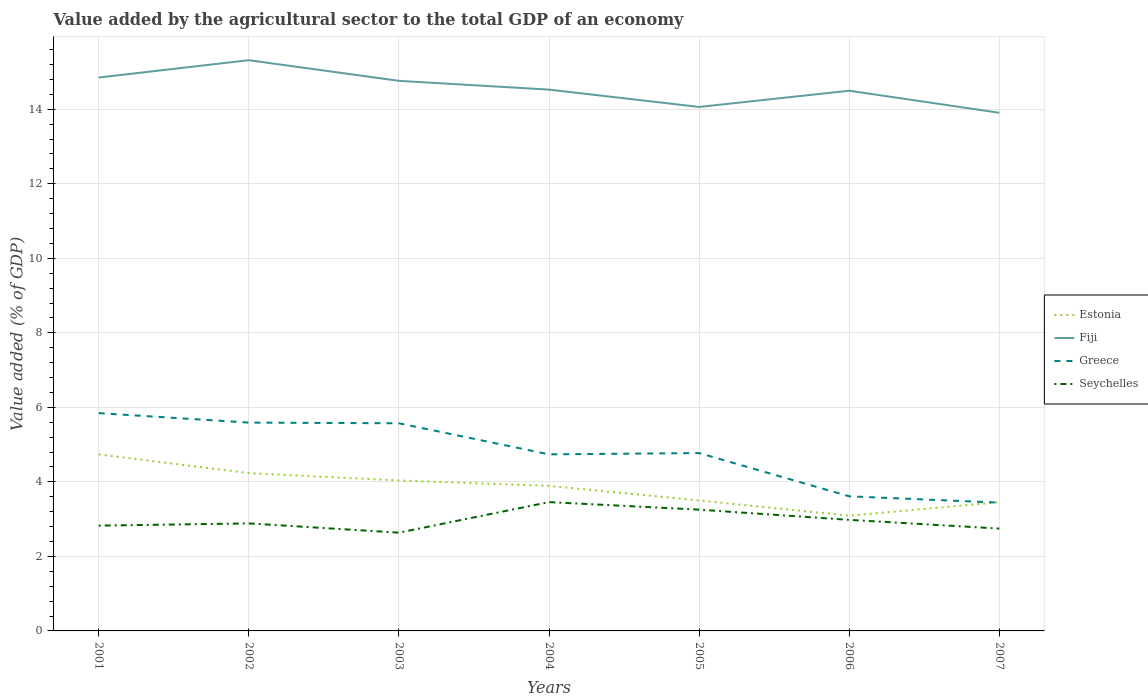How many different coloured lines are there?
Keep it short and to the point. 4. Across all years, what is the maximum value added by the agricultural sector to the total GDP in Fiji?
Your answer should be compact. 13.91. What is the total value added by the agricultural sector to the total GDP in Estonia in the graph?
Your answer should be compact. 1.14. What is the difference between the highest and the second highest value added by the agricultural sector to the total GDP in Fiji?
Give a very brief answer. 1.41. How many lines are there?
Your response must be concise. 4. How many years are there in the graph?
Your answer should be compact. 7. What is the difference between two consecutive major ticks on the Y-axis?
Your answer should be very brief. 2. Are the values on the major ticks of Y-axis written in scientific E-notation?
Offer a terse response. No. Does the graph contain grids?
Give a very brief answer. Yes. Where does the legend appear in the graph?
Your answer should be very brief. Center right. How many legend labels are there?
Offer a terse response. 4. What is the title of the graph?
Your answer should be compact. Value added by the agricultural sector to the total GDP of an economy. Does "Nigeria" appear as one of the legend labels in the graph?
Offer a terse response. No. What is the label or title of the Y-axis?
Give a very brief answer. Value added (% of GDP). What is the Value added (% of GDP) of Estonia in 2001?
Your answer should be very brief. 4.74. What is the Value added (% of GDP) of Fiji in 2001?
Your answer should be compact. 14.85. What is the Value added (% of GDP) of Greece in 2001?
Ensure brevity in your answer.  5.84. What is the Value added (% of GDP) in Seychelles in 2001?
Provide a succinct answer. 2.83. What is the Value added (% of GDP) in Estonia in 2002?
Provide a succinct answer. 4.23. What is the Value added (% of GDP) of Fiji in 2002?
Offer a terse response. 15.32. What is the Value added (% of GDP) of Greece in 2002?
Your answer should be compact. 5.59. What is the Value added (% of GDP) in Seychelles in 2002?
Provide a short and direct response. 2.89. What is the Value added (% of GDP) in Estonia in 2003?
Your answer should be compact. 4.04. What is the Value added (% of GDP) in Fiji in 2003?
Give a very brief answer. 14.76. What is the Value added (% of GDP) in Greece in 2003?
Offer a terse response. 5.57. What is the Value added (% of GDP) of Seychelles in 2003?
Your response must be concise. 2.64. What is the Value added (% of GDP) of Estonia in 2004?
Give a very brief answer. 3.89. What is the Value added (% of GDP) of Fiji in 2004?
Your response must be concise. 14.53. What is the Value added (% of GDP) in Greece in 2004?
Your answer should be very brief. 4.74. What is the Value added (% of GDP) in Seychelles in 2004?
Provide a short and direct response. 3.46. What is the Value added (% of GDP) in Estonia in 2005?
Provide a succinct answer. 3.5. What is the Value added (% of GDP) in Fiji in 2005?
Keep it short and to the point. 14.06. What is the Value added (% of GDP) in Greece in 2005?
Make the answer very short. 4.77. What is the Value added (% of GDP) in Seychelles in 2005?
Your answer should be compact. 3.25. What is the Value added (% of GDP) of Estonia in 2006?
Make the answer very short. 3.09. What is the Value added (% of GDP) of Fiji in 2006?
Offer a very short reply. 14.5. What is the Value added (% of GDP) in Greece in 2006?
Your answer should be compact. 3.61. What is the Value added (% of GDP) in Seychelles in 2006?
Give a very brief answer. 2.98. What is the Value added (% of GDP) in Estonia in 2007?
Offer a very short reply. 3.46. What is the Value added (% of GDP) of Fiji in 2007?
Your answer should be compact. 13.91. What is the Value added (% of GDP) in Greece in 2007?
Provide a short and direct response. 3.44. What is the Value added (% of GDP) of Seychelles in 2007?
Keep it short and to the point. 2.75. Across all years, what is the maximum Value added (% of GDP) of Estonia?
Ensure brevity in your answer.  4.74. Across all years, what is the maximum Value added (% of GDP) in Fiji?
Make the answer very short. 15.32. Across all years, what is the maximum Value added (% of GDP) of Greece?
Give a very brief answer. 5.84. Across all years, what is the maximum Value added (% of GDP) in Seychelles?
Ensure brevity in your answer.  3.46. Across all years, what is the minimum Value added (% of GDP) of Estonia?
Keep it short and to the point. 3.09. Across all years, what is the minimum Value added (% of GDP) of Fiji?
Ensure brevity in your answer.  13.91. Across all years, what is the minimum Value added (% of GDP) in Greece?
Provide a succinct answer. 3.44. Across all years, what is the minimum Value added (% of GDP) of Seychelles?
Make the answer very short. 2.64. What is the total Value added (% of GDP) in Estonia in the graph?
Give a very brief answer. 26.95. What is the total Value added (% of GDP) of Fiji in the graph?
Keep it short and to the point. 101.93. What is the total Value added (% of GDP) of Greece in the graph?
Provide a succinct answer. 33.58. What is the total Value added (% of GDP) of Seychelles in the graph?
Ensure brevity in your answer.  20.79. What is the difference between the Value added (% of GDP) of Estonia in 2001 and that in 2002?
Keep it short and to the point. 0.5. What is the difference between the Value added (% of GDP) of Fiji in 2001 and that in 2002?
Provide a succinct answer. -0.46. What is the difference between the Value added (% of GDP) of Greece in 2001 and that in 2002?
Make the answer very short. 0.25. What is the difference between the Value added (% of GDP) of Seychelles in 2001 and that in 2002?
Your answer should be very brief. -0.06. What is the difference between the Value added (% of GDP) of Estonia in 2001 and that in 2003?
Make the answer very short. 0.7. What is the difference between the Value added (% of GDP) in Fiji in 2001 and that in 2003?
Your response must be concise. 0.09. What is the difference between the Value added (% of GDP) in Greece in 2001 and that in 2003?
Provide a short and direct response. 0.27. What is the difference between the Value added (% of GDP) in Seychelles in 2001 and that in 2003?
Give a very brief answer. 0.19. What is the difference between the Value added (% of GDP) in Estonia in 2001 and that in 2004?
Your answer should be compact. 0.84. What is the difference between the Value added (% of GDP) in Fiji in 2001 and that in 2004?
Offer a very short reply. 0.32. What is the difference between the Value added (% of GDP) in Greece in 2001 and that in 2004?
Your answer should be very brief. 1.11. What is the difference between the Value added (% of GDP) of Seychelles in 2001 and that in 2004?
Ensure brevity in your answer.  -0.63. What is the difference between the Value added (% of GDP) of Estonia in 2001 and that in 2005?
Keep it short and to the point. 1.24. What is the difference between the Value added (% of GDP) in Fiji in 2001 and that in 2005?
Provide a short and direct response. 0.79. What is the difference between the Value added (% of GDP) of Greece in 2001 and that in 2005?
Provide a short and direct response. 1.07. What is the difference between the Value added (% of GDP) in Seychelles in 2001 and that in 2005?
Offer a very short reply. -0.43. What is the difference between the Value added (% of GDP) in Estonia in 2001 and that in 2006?
Your response must be concise. 1.65. What is the difference between the Value added (% of GDP) of Fiji in 2001 and that in 2006?
Offer a very short reply. 0.35. What is the difference between the Value added (% of GDP) in Greece in 2001 and that in 2006?
Offer a very short reply. 2.23. What is the difference between the Value added (% of GDP) in Seychelles in 2001 and that in 2006?
Offer a terse response. -0.15. What is the difference between the Value added (% of GDP) in Estonia in 2001 and that in 2007?
Your answer should be very brief. 1.28. What is the difference between the Value added (% of GDP) in Fiji in 2001 and that in 2007?
Offer a very short reply. 0.95. What is the difference between the Value added (% of GDP) in Greece in 2001 and that in 2007?
Offer a very short reply. 2.4. What is the difference between the Value added (% of GDP) of Seychelles in 2001 and that in 2007?
Keep it short and to the point. 0.08. What is the difference between the Value added (% of GDP) of Estonia in 2002 and that in 2003?
Ensure brevity in your answer.  0.2. What is the difference between the Value added (% of GDP) in Fiji in 2002 and that in 2003?
Give a very brief answer. 0.55. What is the difference between the Value added (% of GDP) in Greece in 2002 and that in 2003?
Keep it short and to the point. 0.02. What is the difference between the Value added (% of GDP) of Seychelles in 2002 and that in 2003?
Ensure brevity in your answer.  0.25. What is the difference between the Value added (% of GDP) of Estonia in 2002 and that in 2004?
Provide a succinct answer. 0.34. What is the difference between the Value added (% of GDP) of Fiji in 2002 and that in 2004?
Your response must be concise. 0.79. What is the difference between the Value added (% of GDP) of Greece in 2002 and that in 2004?
Your answer should be compact. 0.85. What is the difference between the Value added (% of GDP) of Seychelles in 2002 and that in 2004?
Your answer should be very brief. -0.57. What is the difference between the Value added (% of GDP) of Estonia in 2002 and that in 2005?
Your answer should be very brief. 0.73. What is the difference between the Value added (% of GDP) of Fiji in 2002 and that in 2005?
Offer a terse response. 1.25. What is the difference between the Value added (% of GDP) in Greece in 2002 and that in 2005?
Provide a succinct answer. 0.82. What is the difference between the Value added (% of GDP) of Seychelles in 2002 and that in 2005?
Your answer should be compact. -0.37. What is the difference between the Value added (% of GDP) in Estonia in 2002 and that in 2006?
Provide a short and direct response. 1.14. What is the difference between the Value added (% of GDP) of Fiji in 2002 and that in 2006?
Ensure brevity in your answer.  0.82. What is the difference between the Value added (% of GDP) in Greece in 2002 and that in 2006?
Your response must be concise. 1.98. What is the difference between the Value added (% of GDP) in Seychelles in 2002 and that in 2006?
Keep it short and to the point. -0.1. What is the difference between the Value added (% of GDP) in Estonia in 2002 and that in 2007?
Ensure brevity in your answer.  0.78. What is the difference between the Value added (% of GDP) of Fiji in 2002 and that in 2007?
Make the answer very short. 1.41. What is the difference between the Value added (% of GDP) of Greece in 2002 and that in 2007?
Provide a short and direct response. 2.15. What is the difference between the Value added (% of GDP) of Seychelles in 2002 and that in 2007?
Give a very brief answer. 0.14. What is the difference between the Value added (% of GDP) in Estonia in 2003 and that in 2004?
Offer a very short reply. 0.14. What is the difference between the Value added (% of GDP) in Fiji in 2003 and that in 2004?
Offer a very short reply. 0.24. What is the difference between the Value added (% of GDP) in Greece in 2003 and that in 2004?
Your answer should be compact. 0.83. What is the difference between the Value added (% of GDP) in Seychelles in 2003 and that in 2004?
Offer a terse response. -0.82. What is the difference between the Value added (% of GDP) of Estonia in 2003 and that in 2005?
Your answer should be very brief. 0.54. What is the difference between the Value added (% of GDP) in Fiji in 2003 and that in 2005?
Give a very brief answer. 0.7. What is the difference between the Value added (% of GDP) of Greece in 2003 and that in 2005?
Your answer should be very brief. 0.8. What is the difference between the Value added (% of GDP) of Seychelles in 2003 and that in 2005?
Offer a terse response. -0.62. What is the difference between the Value added (% of GDP) in Estonia in 2003 and that in 2006?
Your answer should be compact. 0.94. What is the difference between the Value added (% of GDP) of Fiji in 2003 and that in 2006?
Provide a succinct answer. 0.27. What is the difference between the Value added (% of GDP) in Greece in 2003 and that in 2006?
Keep it short and to the point. 1.96. What is the difference between the Value added (% of GDP) in Seychelles in 2003 and that in 2006?
Provide a short and direct response. -0.34. What is the difference between the Value added (% of GDP) of Estonia in 2003 and that in 2007?
Your answer should be very brief. 0.58. What is the difference between the Value added (% of GDP) of Fiji in 2003 and that in 2007?
Provide a succinct answer. 0.86. What is the difference between the Value added (% of GDP) of Greece in 2003 and that in 2007?
Give a very brief answer. 2.13. What is the difference between the Value added (% of GDP) in Seychelles in 2003 and that in 2007?
Offer a very short reply. -0.11. What is the difference between the Value added (% of GDP) of Estonia in 2004 and that in 2005?
Provide a short and direct response. 0.39. What is the difference between the Value added (% of GDP) of Fiji in 2004 and that in 2005?
Offer a terse response. 0.47. What is the difference between the Value added (% of GDP) in Greece in 2004 and that in 2005?
Ensure brevity in your answer.  -0.03. What is the difference between the Value added (% of GDP) of Seychelles in 2004 and that in 2005?
Your answer should be very brief. 0.2. What is the difference between the Value added (% of GDP) in Estonia in 2004 and that in 2006?
Provide a short and direct response. 0.8. What is the difference between the Value added (% of GDP) of Greece in 2004 and that in 2006?
Give a very brief answer. 1.13. What is the difference between the Value added (% of GDP) of Seychelles in 2004 and that in 2006?
Give a very brief answer. 0.48. What is the difference between the Value added (% of GDP) in Estonia in 2004 and that in 2007?
Provide a succinct answer. 0.44. What is the difference between the Value added (% of GDP) of Fiji in 2004 and that in 2007?
Your answer should be compact. 0.62. What is the difference between the Value added (% of GDP) in Greece in 2004 and that in 2007?
Your response must be concise. 1.3. What is the difference between the Value added (% of GDP) in Seychelles in 2004 and that in 2007?
Ensure brevity in your answer.  0.71. What is the difference between the Value added (% of GDP) of Estonia in 2005 and that in 2006?
Your answer should be very brief. 0.41. What is the difference between the Value added (% of GDP) of Fiji in 2005 and that in 2006?
Ensure brevity in your answer.  -0.44. What is the difference between the Value added (% of GDP) in Greece in 2005 and that in 2006?
Your response must be concise. 1.16. What is the difference between the Value added (% of GDP) of Seychelles in 2005 and that in 2006?
Provide a succinct answer. 0.27. What is the difference between the Value added (% of GDP) in Estonia in 2005 and that in 2007?
Keep it short and to the point. 0.05. What is the difference between the Value added (% of GDP) of Fiji in 2005 and that in 2007?
Offer a terse response. 0.16. What is the difference between the Value added (% of GDP) in Greece in 2005 and that in 2007?
Give a very brief answer. 1.33. What is the difference between the Value added (% of GDP) of Seychelles in 2005 and that in 2007?
Your response must be concise. 0.51. What is the difference between the Value added (% of GDP) of Estonia in 2006 and that in 2007?
Your answer should be very brief. -0.36. What is the difference between the Value added (% of GDP) in Fiji in 2006 and that in 2007?
Your answer should be compact. 0.59. What is the difference between the Value added (% of GDP) of Greece in 2006 and that in 2007?
Offer a terse response. 0.17. What is the difference between the Value added (% of GDP) of Seychelles in 2006 and that in 2007?
Make the answer very short. 0.23. What is the difference between the Value added (% of GDP) in Estonia in 2001 and the Value added (% of GDP) in Fiji in 2002?
Make the answer very short. -10.58. What is the difference between the Value added (% of GDP) of Estonia in 2001 and the Value added (% of GDP) of Greece in 2002?
Your answer should be compact. -0.85. What is the difference between the Value added (% of GDP) of Estonia in 2001 and the Value added (% of GDP) of Seychelles in 2002?
Make the answer very short. 1.85. What is the difference between the Value added (% of GDP) in Fiji in 2001 and the Value added (% of GDP) in Greece in 2002?
Your answer should be very brief. 9.26. What is the difference between the Value added (% of GDP) of Fiji in 2001 and the Value added (% of GDP) of Seychelles in 2002?
Your answer should be very brief. 11.97. What is the difference between the Value added (% of GDP) of Greece in 2001 and the Value added (% of GDP) of Seychelles in 2002?
Your answer should be very brief. 2.96. What is the difference between the Value added (% of GDP) in Estonia in 2001 and the Value added (% of GDP) in Fiji in 2003?
Your answer should be compact. -10.03. What is the difference between the Value added (% of GDP) in Estonia in 2001 and the Value added (% of GDP) in Greece in 2003?
Make the answer very short. -0.83. What is the difference between the Value added (% of GDP) in Estonia in 2001 and the Value added (% of GDP) in Seychelles in 2003?
Keep it short and to the point. 2.1. What is the difference between the Value added (% of GDP) of Fiji in 2001 and the Value added (% of GDP) of Greece in 2003?
Provide a succinct answer. 9.28. What is the difference between the Value added (% of GDP) of Fiji in 2001 and the Value added (% of GDP) of Seychelles in 2003?
Make the answer very short. 12.22. What is the difference between the Value added (% of GDP) in Greece in 2001 and the Value added (% of GDP) in Seychelles in 2003?
Provide a short and direct response. 3.21. What is the difference between the Value added (% of GDP) of Estonia in 2001 and the Value added (% of GDP) of Fiji in 2004?
Ensure brevity in your answer.  -9.79. What is the difference between the Value added (% of GDP) of Estonia in 2001 and the Value added (% of GDP) of Greece in 2004?
Your answer should be very brief. -0. What is the difference between the Value added (% of GDP) in Estonia in 2001 and the Value added (% of GDP) in Seychelles in 2004?
Give a very brief answer. 1.28. What is the difference between the Value added (% of GDP) in Fiji in 2001 and the Value added (% of GDP) in Greece in 2004?
Your response must be concise. 10.11. What is the difference between the Value added (% of GDP) of Fiji in 2001 and the Value added (% of GDP) of Seychelles in 2004?
Your response must be concise. 11.4. What is the difference between the Value added (% of GDP) in Greece in 2001 and the Value added (% of GDP) in Seychelles in 2004?
Provide a succinct answer. 2.39. What is the difference between the Value added (% of GDP) in Estonia in 2001 and the Value added (% of GDP) in Fiji in 2005?
Your response must be concise. -9.32. What is the difference between the Value added (% of GDP) in Estonia in 2001 and the Value added (% of GDP) in Greece in 2005?
Your answer should be compact. -0.04. What is the difference between the Value added (% of GDP) of Estonia in 2001 and the Value added (% of GDP) of Seychelles in 2005?
Your answer should be very brief. 1.48. What is the difference between the Value added (% of GDP) of Fiji in 2001 and the Value added (% of GDP) of Greece in 2005?
Offer a terse response. 10.08. What is the difference between the Value added (% of GDP) in Fiji in 2001 and the Value added (% of GDP) in Seychelles in 2005?
Make the answer very short. 11.6. What is the difference between the Value added (% of GDP) in Greece in 2001 and the Value added (% of GDP) in Seychelles in 2005?
Make the answer very short. 2.59. What is the difference between the Value added (% of GDP) in Estonia in 2001 and the Value added (% of GDP) in Fiji in 2006?
Give a very brief answer. -9.76. What is the difference between the Value added (% of GDP) of Estonia in 2001 and the Value added (% of GDP) of Greece in 2006?
Keep it short and to the point. 1.13. What is the difference between the Value added (% of GDP) of Estonia in 2001 and the Value added (% of GDP) of Seychelles in 2006?
Your answer should be compact. 1.76. What is the difference between the Value added (% of GDP) of Fiji in 2001 and the Value added (% of GDP) of Greece in 2006?
Your answer should be compact. 11.24. What is the difference between the Value added (% of GDP) of Fiji in 2001 and the Value added (% of GDP) of Seychelles in 2006?
Offer a very short reply. 11.87. What is the difference between the Value added (% of GDP) in Greece in 2001 and the Value added (% of GDP) in Seychelles in 2006?
Provide a succinct answer. 2.86. What is the difference between the Value added (% of GDP) of Estonia in 2001 and the Value added (% of GDP) of Fiji in 2007?
Give a very brief answer. -9.17. What is the difference between the Value added (% of GDP) in Estonia in 2001 and the Value added (% of GDP) in Greece in 2007?
Ensure brevity in your answer.  1.29. What is the difference between the Value added (% of GDP) in Estonia in 2001 and the Value added (% of GDP) in Seychelles in 2007?
Your answer should be compact. 1.99. What is the difference between the Value added (% of GDP) of Fiji in 2001 and the Value added (% of GDP) of Greece in 2007?
Give a very brief answer. 11.41. What is the difference between the Value added (% of GDP) of Fiji in 2001 and the Value added (% of GDP) of Seychelles in 2007?
Provide a succinct answer. 12.11. What is the difference between the Value added (% of GDP) in Greece in 2001 and the Value added (% of GDP) in Seychelles in 2007?
Your response must be concise. 3.1. What is the difference between the Value added (% of GDP) in Estonia in 2002 and the Value added (% of GDP) in Fiji in 2003?
Provide a short and direct response. -10.53. What is the difference between the Value added (% of GDP) in Estonia in 2002 and the Value added (% of GDP) in Greece in 2003?
Provide a succinct answer. -1.34. What is the difference between the Value added (% of GDP) in Estonia in 2002 and the Value added (% of GDP) in Seychelles in 2003?
Ensure brevity in your answer.  1.6. What is the difference between the Value added (% of GDP) in Fiji in 2002 and the Value added (% of GDP) in Greece in 2003?
Give a very brief answer. 9.74. What is the difference between the Value added (% of GDP) in Fiji in 2002 and the Value added (% of GDP) in Seychelles in 2003?
Provide a short and direct response. 12.68. What is the difference between the Value added (% of GDP) in Greece in 2002 and the Value added (% of GDP) in Seychelles in 2003?
Make the answer very short. 2.95. What is the difference between the Value added (% of GDP) in Estonia in 2002 and the Value added (% of GDP) in Fiji in 2004?
Ensure brevity in your answer.  -10.29. What is the difference between the Value added (% of GDP) in Estonia in 2002 and the Value added (% of GDP) in Greece in 2004?
Ensure brevity in your answer.  -0.5. What is the difference between the Value added (% of GDP) in Estonia in 2002 and the Value added (% of GDP) in Seychelles in 2004?
Provide a short and direct response. 0.78. What is the difference between the Value added (% of GDP) of Fiji in 2002 and the Value added (% of GDP) of Greece in 2004?
Ensure brevity in your answer.  10.58. What is the difference between the Value added (% of GDP) of Fiji in 2002 and the Value added (% of GDP) of Seychelles in 2004?
Provide a succinct answer. 11.86. What is the difference between the Value added (% of GDP) of Greece in 2002 and the Value added (% of GDP) of Seychelles in 2004?
Provide a succinct answer. 2.13. What is the difference between the Value added (% of GDP) of Estonia in 2002 and the Value added (% of GDP) of Fiji in 2005?
Ensure brevity in your answer.  -9.83. What is the difference between the Value added (% of GDP) of Estonia in 2002 and the Value added (% of GDP) of Greece in 2005?
Provide a short and direct response. -0.54. What is the difference between the Value added (% of GDP) of Estonia in 2002 and the Value added (% of GDP) of Seychelles in 2005?
Offer a very short reply. 0.98. What is the difference between the Value added (% of GDP) of Fiji in 2002 and the Value added (% of GDP) of Greece in 2005?
Ensure brevity in your answer.  10.54. What is the difference between the Value added (% of GDP) of Fiji in 2002 and the Value added (% of GDP) of Seychelles in 2005?
Provide a succinct answer. 12.06. What is the difference between the Value added (% of GDP) of Greece in 2002 and the Value added (% of GDP) of Seychelles in 2005?
Your answer should be compact. 2.34. What is the difference between the Value added (% of GDP) in Estonia in 2002 and the Value added (% of GDP) in Fiji in 2006?
Keep it short and to the point. -10.26. What is the difference between the Value added (% of GDP) of Estonia in 2002 and the Value added (% of GDP) of Greece in 2006?
Your answer should be very brief. 0.62. What is the difference between the Value added (% of GDP) of Estonia in 2002 and the Value added (% of GDP) of Seychelles in 2006?
Ensure brevity in your answer.  1.25. What is the difference between the Value added (% of GDP) of Fiji in 2002 and the Value added (% of GDP) of Greece in 2006?
Offer a terse response. 11.7. What is the difference between the Value added (% of GDP) in Fiji in 2002 and the Value added (% of GDP) in Seychelles in 2006?
Offer a very short reply. 12.34. What is the difference between the Value added (% of GDP) in Greece in 2002 and the Value added (% of GDP) in Seychelles in 2006?
Provide a short and direct response. 2.61. What is the difference between the Value added (% of GDP) of Estonia in 2002 and the Value added (% of GDP) of Fiji in 2007?
Offer a very short reply. -9.67. What is the difference between the Value added (% of GDP) of Estonia in 2002 and the Value added (% of GDP) of Greece in 2007?
Give a very brief answer. 0.79. What is the difference between the Value added (% of GDP) in Estonia in 2002 and the Value added (% of GDP) in Seychelles in 2007?
Offer a terse response. 1.49. What is the difference between the Value added (% of GDP) in Fiji in 2002 and the Value added (% of GDP) in Greece in 2007?
Your response must be concise. 11.87. What is the difference between the Value added (% of GDP) in Fiji in 2002 and the Value added (% of GDP) in Seychelles in 2007?
Give a very brief answer. 12.57. What is the difference between the Value added (% of GDP) in Greece in 2002 and the Value added (% of GDP) in Seychelles in 2007?
Keep it short and to the point. 2.84. What is the difference between the Value added (% of GDP) of Estonia in 2003 and the Value added (% of GDP) of Fiji in 2004?
Make the answer very short. -10.49. What is the difference between the Value added (% of GDP) in Estonia in 2003 and the Value added (% of GDP) in Greece in 2004?
Offer a terse response. -0.7. What is the difference between the Value added (% of GDP) of Estonia in 2003 and the Value added (% of GDP) of Seychelles in 2004?
Offer a terse response. 0.58. What is the difference between the Value added (% of GDP) of Fiji in 2003 and the Value added (% of GDP) of Greece in 2004?
Give a very brief answer. 10.02. What is the difference between the Value added (% of GDP) in Fiji in 2003 and the Value added (% of GDP) in Seychelles in 2004?
Offer a terse response. 11.31. What is the difference between the Value added (% of GDP) of Greece in 2003 and the Value added (% of GDP) of Seychelles in 2004?
Offer a terse response. 2.12. What is the difference between the Value added (% of GDP) in Estonia in 2003 and the Value added (% of GDP) in Fiji in 2005?
Your answer should be very brief. -10.03. What is the difference between the Value added (% of GDP) of Estonia in 2003 and the Value added (% of GDP) of Greece in 2005?
Ensure brevity in your answer.  -0.74. What is the difference between the Value added (% of GDP) in Estonia in 2003 and the Value added (% of GDP) in Seychelles in 2005?
Offer a terse response. 0.78. What is the difference between the Value added (% of GDP) in Fiji in 2003 and the Value added (% of GDP) in Greece in 2005?
Offer a terse response. 9.99. What is the difference between the Value added (% of GDP) in Fiji in 2003 and the Value added (% of GDP) in Seychelles in 2005?
Keep it short and to the point. 11.51. What is the difference between the Value added (% of GDP) of Greece in 2003 and the Value added (% of GDP) of Seychelles in 2005?
Provide a short and direct response. 2.32. What is the difference between the Value added (% of GDP) in Estonia in 2003 and the Value added (% of GDP) in Fiji in 2006?
Your answer should be very brief. -10.46. What is the difference between the Value added (% of GDP) in Estonia in 2003 and the Value added (% of GDP) in Greece in 2006?
Your response must be concise. 0.42. What is the difference between the Value added (% of GDP) in Estonia in 2003 and the Value added (% of GDP) in Seychelles in 2006?
Provide a short and direct response. 1.06. What is the difference between the Value added (% of GDP) of Fiji in 2003 and the Value added (% of GDP) of Greece in 2006?
Your answer should be very brief. 11.15. What is the difference between the Value added (% of GDP) in Fiji in 2003 and the Value added (% of GDP) in Seychelles in 2006?
Provide a short and direct response. 11.78. What is the difference between the Value added (% of GDP) in Greece in 2003 and the Value added (% of GDP) in Seychelles in 2006?
Your answer should be very brief. 2.59. What is the difference between the Value added (% of GDP) of Estonia in 2003 and the Value added (% of GDP) of Fiji in 2007?
Offer a very short reply. -9.87. What is the difference between the Value added (% of GDP) of Estonia in 2003 and the Value added (% of GDP) of Greece in 2007?
Offer a terse response. 0.59. What is the difference between the Value added (% of GDP) in Estonia in 2003 and the Value added (% of GDP) in Seychelles in 2007?
Your response must be concise. 1.29. What is the difference between the Value added (% of GDP) in Fiji in 2003 and the Value added (% of GDP) in Greece in 2007?
Your response must be concise. 11.32. What is the difference between the Value added (% of GDP) in Fiji in 2003 and the Value added (% of GDP) in Seychelles in 2007?
Keep it short and to the point. 12.02. What is the difference between the Value added (% of GDP) in Greece in 2003 and the Value added (% of GDP) in Seychelles in 2007?
Offer a terse response. 2.83. What is the difference between the Value added (% of GDP) in Estonia in 2004 and the Value added (% of GDP) in Fiji in 2005?
Provide a succinct answer. -10.17. What is the difference between the Value added (% of GDP) of Estonia in 2004 and the Value added (% of GDP) of Greece in 2005?
Make the answer very short. -0.88. What is the difference between the Value added (% of GDP) in Estonia in 2004 and the Value added (% of GDP) in Seychelles in 2005?
Give a very brief answer. 0.64. What is the difference between the Value added (% of GDP) in Fiji in 2004 and the Value added (% of GDP) in Greece in 2005?
Provide a short and direct response. 9.75. What is the difference between the Value added (% of GDP) in Fiji in 2004 and the Value added (% of GDP) in Seychelles in 2005?
Your response must be concise. 11.27. What is the difference between the Value added (% of GDP) of Greece in 2004 and the Value added (% of GDP) of Seychelles in 2005?
Ensure brevity in your answer.  1.48. What is the difference between the Value added (% of GDP) of Estonia in 2004 and the Value added (% of GDP) of Fiji in 2006?
Provide a succinct answer. -10.6. What is the difference between the Value added (% of GDP) in Estonia in 2004 and the Value added (% of GDP) in Greece in 2006?
Make the answer very short. 0.28. What is the difference between the Value added (% of GDP) of Estonia in 2004 and the Value added (% of GDP) of Seychelles in 2006?
Keep it short and to the point. 0.91. What is the difference between the Value added (% of GDP) of Fiji in 2004 and the Value added (% of GDP) of Greece in 2006?
Keep it short and to the point. 10.92. What is the difference between the Value added (% of GDP) in Fiji in 2004 and the Value added (% of GDP) in Seychelles in 2006?
Your response must be concise. 11.55. What is the difference between the Value added (% of GDP) in Greece in 2004 and the Value added (% of GDP) in Seychelles in 2006?
Ensure brevity in your answer.  1.76. What is the difference between the Value added (% of GDP) in Estonia in 2004 and the Value added (% of GDP) in Fiji in 2007?
Your answer should be compact. -10.01. What is the difference between the Value added (% of GDP) of Estonia in 2004 and the Value added (% of GDP) of Greece in 2007?
Give a very brief answer. 0.45. What is the difference between the Value added (% of GDP) in Estonia in 2004 and the Value added (% of GDP) in Seychelles in 2007?
Your answer should be compact. 1.15. What is the difference between the Value added (% of GDP) in Fiji in 2004 and the Value added (% of GDP) in Greece in 2007?
Give a very brief answer. 11.08. What is the difference between the Value added (% of GDP) of Fiji in 2004 and the Value added (% of GDP) of Seychelles in 2007?
Offer a terse response. 11.78. What is the difference between the Value added (% of GDP) of Greece in 2004 and the Value added (% of GDP) of Seychelles in 2007?
Keep it short and to the point. 1.99. What is the difference between the Value added (% of GDP) of Estonia in 2005 and the Value added (% of GDP) of Fiji in 2006?
Your answer should be very brief. -11. What is the difference between the Value added (% of GDP) of Estonia in 2005 and the Value added (% of GDP) of Greece in 2006?
Your answer should be compact. -0.11. What is the difference between the Value added (% of GDP) in Estonia in 2005 and the Value added (% of GDP) in Seychelles in 2006?
Ensure brevity in your answer.  0.52. What is the difference between the Value added (% of GDP) in Fiji in 2005 and the Value added (% of GDP) in Greece in 2006?
Give a very brief answer. 10.45. What is the difference between the Value added (% of GDP) of Fiji in 2005 and the Value added (% of GDP) of Seychelles in 2006?
Offer a very short reply. 11.08. What is the difference between the Value added (% of GDP) in Greece in 2005 and the Value added (% of GDP) in Seychelles in 2006?
Your response must be concise. 1.79. What is the difference between the Value added (% of GDP) in Estonia in 2005 and the Value added (% of GDP) in Fiji in 2007?
Offer a terse response. -10.4. What is the difference between the Value added (% of GDP) in Estonia in 2005 and the Value added (% of GDP) in Greece in 2007?
Your response must be concise. 0.06. What is the difference between the Value added (% of GDP) in Estonia in 2005 and the Value added (% of GDP) in Seychelles in 2007?
Your answer should be very brief. 0.75. What is the difference between the Value added (% of GDP) in Fiji in 2005 and the Value added (% of GDP) in Greece in 2007?
Ensure brevity in your answer.  10.62. What is the difference between the Value added (% of GDP) in Fiji in 2005 and the Value added (% of GDP) in Seychelles in 2007?
Ensure brevity in your answer.  11.32. What is the difference between the Value added (% of GDP) of Greece in 2005 and the Value added (% of GDP) of Seychelles in 2007?
Your answer should be compact. 2.03. What is the difference between the Value added (% of GDP) of Estonia in 2006 and the Value added (% of GDP) of Fiji in 2007?
Give a very brief answer. -10.81. What is the difference between the Value added (% of GDP) in Estonia in 2006 and the Value added (% of GDP) in Greece in 2007?
Offer a very short reply. -0.35. What is the difference between the Value added (% of GDP) in Estonia in 2006 and the Value added (% of GDP) in Seychelles in 2007?
Offer a terse response. 0.35. What is the difference between the Value added (% of GDP) in Fiji in 2006 and the Value added (% of GDP) in Greece in 2007?
Offer a very short reply. 11.05. What is the difference between the Value added (% of GDP) in Fiji in 2006 and the Value added (% of GDP) in Seychelles in 2007?
Keep it short and to the point. 11.75. What is the difference between the Value added (% of GDP) of Greece in 2006 and the Value added (% of GDP) of Seychelles in 2007?
Offer a terse response. 0.87. What is the average Value added (% of GDP) in Estonia per year?
Your answer should be compact. 3.85. What is the average Value added (% of GDP) in Fiji per year?
Make the answer very short. 14.56. What is the average Value added (% of GDP) of Greece per year?
Provide a succinct answer. 4.8. What is the average Value added (% of GDP) in Seychelles per year?
Your answer should be very brief. 2.97. In the year 2001, what is the difference between the Value added (% of GDP) in Estonia and Value added (% of GDP) in Fiji?
Your response must be concise. -10.11. In the year 2001, what is the difference between the Value added (% of GDP) of Estonia and Value added (% of GDP) of Greece?
Keep it short and to the point. -1.11. In the year 2001, what is the difference between the Value added (% of GDP) in Estonia and Value added (% of GDP) in Seychelles?
Provide a succinct answer. 1.91. In the year 2001, what is the difference between the Value added (% of GDP) in Fiji and Value added (% of GDP) in Greece?
Make the answer very short. 9.01. In the year 2001, what is the difference between the Value added (% of GDP) in Fiji and Value added (% of GDP) in Seychelles?
Keep it short and to the point. 12.03. In the year 2001, what is the difference between the Value added (% of GDP) of Greece and Value added (% of GDP) of Seychelles?
Offer a terse response. 3.02. In the year 2002, what is the difference between the Value added (% of GDP) in Estonia and Value added (% of GDP) in Fiji?
Make the answer very short. -11.08. In the year 2002, what is the difference between the Value added (% of GDP) of Estonia and Value added (% of GDP) of Greece?
Provide a succinct answer. -1.36. In the year 2002, what is the difference between the Value added (% of GDP) of Estonia and Value added (% of GDP) of Seychelles?
Give a very brief answer. 1.35. In the year 2002, what is the difference between the Value added (% of GDP) in Fiji and Value added (% of GDP) in Greece?
Ensure brevity in your answer.  9.73. In the year 2002, what is the difference between the Value added (% of GDP) in Fiji and Value added (% of GDP) in Seychelles?
Provide a succinct answer. 12.43. In the year 2002, what is the difference between the Value added (% of GDP) in Greece and Value added (% of GDP) in Seychelles?
Make the answer very short. 2.71. In the year 2003, what is the difference between the Value added (% of GDP) in Estonia and Value added (% of GDP) in Fiji?
Provide a succinct answer. -10.73. In the year 2003, what is the difference between the Value added (% of GDP) of Estonia and Value added (% of GDP) of Greece?
Keep it short and to the point. -1.54. In the year 2003, what is the difference between the Value added (% of GDP) in Estonia and Value added (% of GDP) in Seychelles?
Ensure brevity in your answer.  1.4. In the year 2003, what is the difference between the Value added (% of GDP) of Fiji and Value added (% of GDP) of Greece?
Make the answer very short. 9.19. In the year 2003, what is the difference between the Value added (% of GDP) of Fiji and Value added (% of GDP) of Seychelles?
Ensure brevity in your answer.  12.13. In the year 2003, what is the difference between the Value added (% of GDP) of Greece and Value added (% of GDP) of Seychelles?
Ensure brevity in your answer.  2.94. In the year 2004, what is the difference between the Value added (% of GDP) of Estonia and Value added (% of GDP) of Fiji?
Give a very brief answer. -10.63. In the year 2004, what is the difference between the Value added (% of GDP) of Estonia and Value added (% of GDP) of Greece?
Provide a short and direct response. -0.85. In the year 2004, what is the difference between the Value added (% of GDP) in Estonia and Value added (% of GDP) in Seychelles?
Offer a very short reply. 0.44. In the year 2004, what is the difference between the Value added (% of GDP) of Fiji and Value added (% of GDP) of Greece?
Provide a short and direct response. 9.79. In the year 2004, what is the difference between the Value added (% of GDP) of Fiji and Value added (% of GDP) of Seychelles?
Ensure brevity in your answer.  11.07. In the year 2004, what is the difference between the Value added (% of GDP) in Greece and Value added (% of GDP) in Seychelles?
Your response must be concise. 1.28. In the year 2005, what is the difference between the Value added (% of GDP) in Estonia and Value added (% of GDP) in Fiji?
Keep it short and to the point. -10.56. In the year 2005, what is the difference between the Value added (% of GDP) in Estonia and Value added (% of GDP) in Greece?
Make the answer very short. -1.27. In the year 2005, what is the difference between the Value added (% of GDP) of Estonia and Value added (% of GDP) of Seychelles?
Give a very brief answer. 0.25. In the year 2005, what is the difference between the Value added (% of GDP) of Fiji and Value added (% of GDP) of Greece?
Your response must be concise. 9.29. In the year 2005, what is the difference between the Value added (% of GDP) of Fiji and Value added (% of GDP) of Seychelles?
Your answer should be very brief. 10.81. In the year 2005, what is the difference between the Value added (% of GDP) of Greece and Value added (% of GDP) of Seychelles?
Give a very brief answer. 1.52. In the year 2006, what is the difference between the Value added (% of GDP) in Estonia and Value added (% of GDP) in Fiji?
Your answer should be compact. -11.41. In the year 2006, what is the difference between the Value added (% of GDP) of Estonia and Value added (% of GDP) of Greece?
Your answer should be compact. -0.52. In the year 2006, what is the difference between the Value added (% of GDP) of Estonia and Value added (% of GDP) of Seychelles?
Give a very brief answer. 0.11. In the year 2006, what is the difference between the Value added (% of GDP) in Fiji and Value added (% of GDP) in Greece?
Provide a succinct answer. 10.89. In the year 2006, what is the difference between the Value added (% of GDP) of Fiji and Value added (% of GDP) of Seychelles?
Ensure brevity in your answer.  11.52. In the year 2006, what is the difference between the Value added (% of GDP) of Greece and Value added (% of GDP) of Seychelles?
Offer a terse response. 0.63. In the year 2007, what is the difference between the Value added (% of GDP) in Estonia and Value added (% of GDP) in Fiji?
Give a very brief answer. -10.45. In the year 2007, what is the difference between the Value added (% of GDP) in Estonia and Value added (% of GDP) in Greece?
Provide a succinct answer. 0.01. In the year 2007, what is the difference between the Value added (% of GDP) of Estonia and Value added (% of GDP) of Seychelles?
Provide a succinct answer. 0.71. In the year 2007, what is the difference between the Value added (% of GDP) in Fiji and Value added (% of GDP) in Greece?
Provide a short and direct response. 10.46. In the year 2007, what is the difference between the Value added (% of GDP) of Fiji and Value added (% of GDP) of Seychelles?
Offer a very short reply. 11.16. In the year 2007, what is the difference between the Value added (% of GDP) of Greece and Value added (% of GDP) of Seychelles?
Give a very brief answer. 0.7. What is the ratio of the Value added (% of GDP) of Estonia in 2001 to that in 2002?
Offer a terse response. 1.12. What is the ratio of the Value added (% of GDP) of Fiji in 2001 to that in 2002?
Ensure brevity in your answer.  0.97. What is the ratio of the Value added (% of GDP) of Greece in 2001 to that in 2002?
Ensure brevity in your answer.  1.05. What is the ratio of the Value added (% of GDP) in Seychelles in 2001 to that in 2002?
Offer a very short reply. 0.98. What is the ratio of the Value added (% of GDP) of Estonia in 2001 to that in 2003?
Ensure brevity in your answer.  1.17. What is the ratio of the Value added (% of GDP) in Fiji in 2001 to that in 2003?
Provide a succinct answer. 1.01. What is the ratio of the Value added (% of GDP) in Greece in 2001 to that in 2003?
Make the answer very short. 1.05. What is the ratio of the Value added (% of GDP) of Seychelles in 2001 to that in 2003?
Your response must be concise. 1.07. What is the ratio of the Value added (% of GDP) in Estonia in 2001 to that in 2004?
Provide a succinct answer. 1.22. What is the ratio of the Value added (% of GDP) in Fiji in 2001 to that in 2004?
Offer a very short reply. 1.02. What is the ratio of the Value added (% of GDP) in Greece in 2001 to that in 2004?
Your answer should be very brief. 1.23. What is the ratio of the Value added (% of GDP) of Seychelles in 2001 to that in 2004?
Your response must be concise. 0.82. What is the ratio of the Value added (% of GDP) in Estonia in 2001 to that in 2005?
Ensure brevity in your answer.  1.35. What is the ratio of the Value added (% of GDP) of Fiji in 2001 to that in 2005?
Ensure brevity in your answer.  1.06. What is the ratio of the Value added (% of GDP) of Greece in 2001 to that in 2005?
Make the answer very short. 1.22. What is the ratio of the Value added (% of GDP) in Seychelles in 2001 to that in 2005?
Provide a succinct answer. 0.87. What is the ratio of the Value added (% of GDP) in Estonia in 2001 to that in 2006?
Give a very brief answer. 1.53. What is the ratio of the Value added (% of GDP) in Fiji in 2001 to that in 2006?
Your answer should be compact. 1.02. What is the ratio of the Value added (% of GDP) in Greece in 2001 to that in 2006?
Ensure brevity in your answer.  1.62. What is the ratio of the Value added (% of GDP) in Seychelles in 2001 to that in 2006?
Provide a short and direct response. 0.95. What is the ratio of the Value added (% of GDP) in Estonia in 2001 to that in 2007?
Your answer should be very brief. 1.37. What is the ratio of the Value added (% of GDP) in Fiji in 2001 to that in 2007?
Give a very brief answer. 1.07. What is the ratio of the Value added (% of GDP) in Greece in 2001 to that in 2007?
Provide a short and direct response. 1.7. What is the ratio of the Value added (% of GDP) of Seychelles in 2001 to that in 2007?
Give a very brief answer. 1.03. What is the ratio of the Value added (% of GDP) in Estonia in 2002 to that in 2003?
Your response must be concise. 1.05. What is the ratio of the Value added (% of GDP) of Fiji in 2002 to that in 2003?
Keep it short and to the point. 1.04. What is the ratio of the Value added (% of GDP) of Seychelles in 2002 to that in 2003?
Provide a succinct answer. 1.09. What is the ratio of the Value added (% of GDP) in Estonia in 2002 to that in 2004?
Provide a succinct answer. 1.09. What is the ratio of the Value added (% of GDP) of Fiji in 2002 to that in 2004?
Give a very brief answer. 1.05. What is the ratio of the Value added (% of GDP) of Greece in 2002 to that in 2004?
Your answer should be very brief. 1.18. What is the ratio of the Value added (% of GDP) of Seychelles in 2002 to that in 2004?
Your answer should be very brief. 0.83. What is the ratio of the Value added (% of GDP) of Estonia in 2002 to that in 2005?
Your answer should be compact. 1.21. What is the ratio of the Value added (% of GDP) of Fiji in 2002 to that in 2005?
Keep it short and to the point. 1.09. What is the ratio of the Value added (% of GDP) of Greece in 2002 to that in 2005?
Provide a short and direct response. 1.17. What is the ratio of the Value added (% of GDP) of Seychelles in 2002 to that in 2005?
Keep it short and to the point. 0.89. What is the ratio of the Value added (% of GDP) in Estonia in 2002 to that in 2006?
Make the answer very short. 1.37. What is the ratio of the Value added (% of GDP) in Fiji in 2002 to that in 2006?
Offer a very short reply. 1.06. What is the ratio of the Value added (% of GDP) of Greece in 2002 to that in 2006?
Your answer should be compact. 1.55. What is the ratio of the Value added (% of GDP) in Seychelles in 2002 to that in 2006?
Offer a terse response. 0.97. What is the ratio of the Value added (% of GDP) in Estonia in 2002 to that in 2007?
Your answer should be compact. 1.23. What is the ratio of the Value added (% of GDP) of Fiji in 2002 to that in 2007?
Provide a short and direct response. 1.1. What is the ratio of the Value added (% of GDP) in Greece in 2002 to that in 2007?
Offer a very short reply. 1.62. What is the ratio of the Value added (% of GDP) in Seychelles in 2002 to that in 2007?
Ensure brevity in your answer.  1.05. What is the ratio of the Value added (% of GDP) in Fiji in 2003 to that in 2004?
Your answer should be compact. 1.02. What is the ratio of the Value added (% of GDP) in Greece in 2003 to that in 2004?
Make the answer very short. 1.18. What is the ratio of the Value added (% of GDP) of Seychelles in 2003 to that in 2004?
Ensure brevity in your answer.  0.76. What is the ratio of the Value added (% of GDP) of Estonia in 2003 to that in 2005?
Your answer should be very brief. 1.15. What is the ratio of the Value added (% of GDP) of Fiji in 2003 to that in 2005?
Provide a short and direct response. 1.05. What is the ratio of the Value added (% of GDP) in Greece in 2003 to that in 2005?
Give a very brief answer. 1.17. What is the ratio of the Value added (% of GDP) of Seychelles in 2003 to that in 2005?
Keep it short and to the point. 0.81. What is the ratio of the Value added (% of GDP) in Estonia in 2003 to that in 2006?
Make the answer very short. 1.31. What is the ratio of the Value added (% of GDP) of Fiji in 2003 to that in 2006?
Your answer should be very brief. 1.02. What is the ratio of the Value added (% of GDP) in Greece in 2003 to that in 2006?
Your answer should be compact. 1.54. What is the ratio of the Value added (% of GDP) in Seychelles in 2003 to that in 2006?
Keep it short and to the point. 0.88. What is the ratio of the Value added (% of GDP) of Estonia in 2003 to that in 2007?
Offer a terse response. 1.17. What is the ratio of the Value added (% of GDP) in Fiji in 2003 to that in 2007?
Your answer should be very brief. 1.06. What is the ratio of the Value added (% of GDP) in Greece in 2003 to that in 2007?
Your answer should be very brief. 1.62. What is the ratio of the Value added (% of GDP) of Seychelles in 2003 to that in 2007?
Your answer should be compact. 0.96. What is the ratio of the Value added (% of GDP) of Estonia in 2004 to that in 2005?
Offer a very short reply. 1.11. What is the ratio of the Value added (% of GDP) in Fiji in 2004 to that in 2005?
Offer a terse response. 1.03. What is the ratio of the Value added (% of GDP) of Seychelles in 2004 to that in 2005?
Provide a short and direct response. 1.06. What is the ratio of the Value added (% of GDP) in Estonia in 2004 to that in 2006?
Your answer should be very brief. 1.26. What is the ratio of the Value added (% of GDP) of Greece in 2004 to that in 2006?
Offer a terse response. 1.31. What is the ratio of the Value added (% of GDP) in Seychelles in 2004 to that in 2006?
Provide a short and direct response. 1.16. What is the ratio of the Value added (% of GDP) in Estonia in 2004 to that in 2007?
Keep it short and to the point. 1.13. What is the ratio of the Value added (% of GDP) of Fiji in 2004 to that in 2007?
Offer a terse response. 1.04. What is the ratio of the Value added (% of GDP) of Greece in 2004 to that in 2007?
Your answer should be very brief. 1.38. What is the ratio of the Value added (% of GDP) of Seychelles in 2004 to that in 2007?
Offer a very short reply. 1.26. What is the ratio of the Value added (% of GDP) in Estonia in 2005 to that in 2006?
Make the answer very short. 1.13. What is the ratio of the Value added (% of GDP) in Greece in 2005 to that in 2006?
Provide a succinct answer. 1.32. What is the ratio of the Value added (% of GDP) in Seychelles in 2005 to that in 2006?
Offer a very short reply. 1.09. What is the ratio of the Value added (% of GDP) of Estonia in 2005 to that in 2007?
Ensure brevity in your answer.  1.01. What is the ratio of the Value added (% of GDP) of Fiji in 2005 to that in 2007?
Provide a short and direct response. 1.01. What is the ratio of the Value added (% of GDP) of Greece in 2005 to that in 2007?
Make the answer very short. 1.39. What is the ratio of the Value added (% of GDP) in Seychelles in 2005 to that in 2007?
Your response must be concise. 1.19. What is the ratio of the Value added (% of GDP) in Estonia in 2006 to that in 2007?
Keep it short and to the point. 0.9. What is the ratio of the Value added (% of GDP) in Fiji in 2006 to that in 2007?
Keep it short and to the point. 1.04. What is the ratio of the Value added (% of GDP) in Greece in 2006 to that in 2007?
Provide a succinct answer. 1.05. What is the ratio of the Value added (% of GDP) of Seychelles in 2006 to that in 2007?
Your answer should be very brief. 1.09. What is the difference between the highest and the second highest Value added (% of GDP) in Estonia?
Offer a very short reply. 0.5. What is the difference between the highest and the second highest Value added (% of GDP) in Fiji?
Give a very brief answer. 0.46. What is the difference between the highest and the second highest Value added (% of GDP) of Greece?
Ensure brevity in your answer.  0.25. What is the difference between the highest and the second highest Value added (% of GDP) of Seychelles?
Provide a succinct answer. 0.2. What is the difference between the highest and the lowest Value added (% of GDP) in Estonia?
Your response must be concise. 1.65. What is the difference between the highest and the lowest Value added (% of GDP) in Fiji?
Your answer should be compact. 1.41. What is the difference between the highest and the lowest Value added (% of GDP) in Greece?
Your answer should be compact. 2.4. What is the difference between the highest and the lowest Value added (% of GDP) of Seychelles?
Provide a short and direct response. 0.82. 